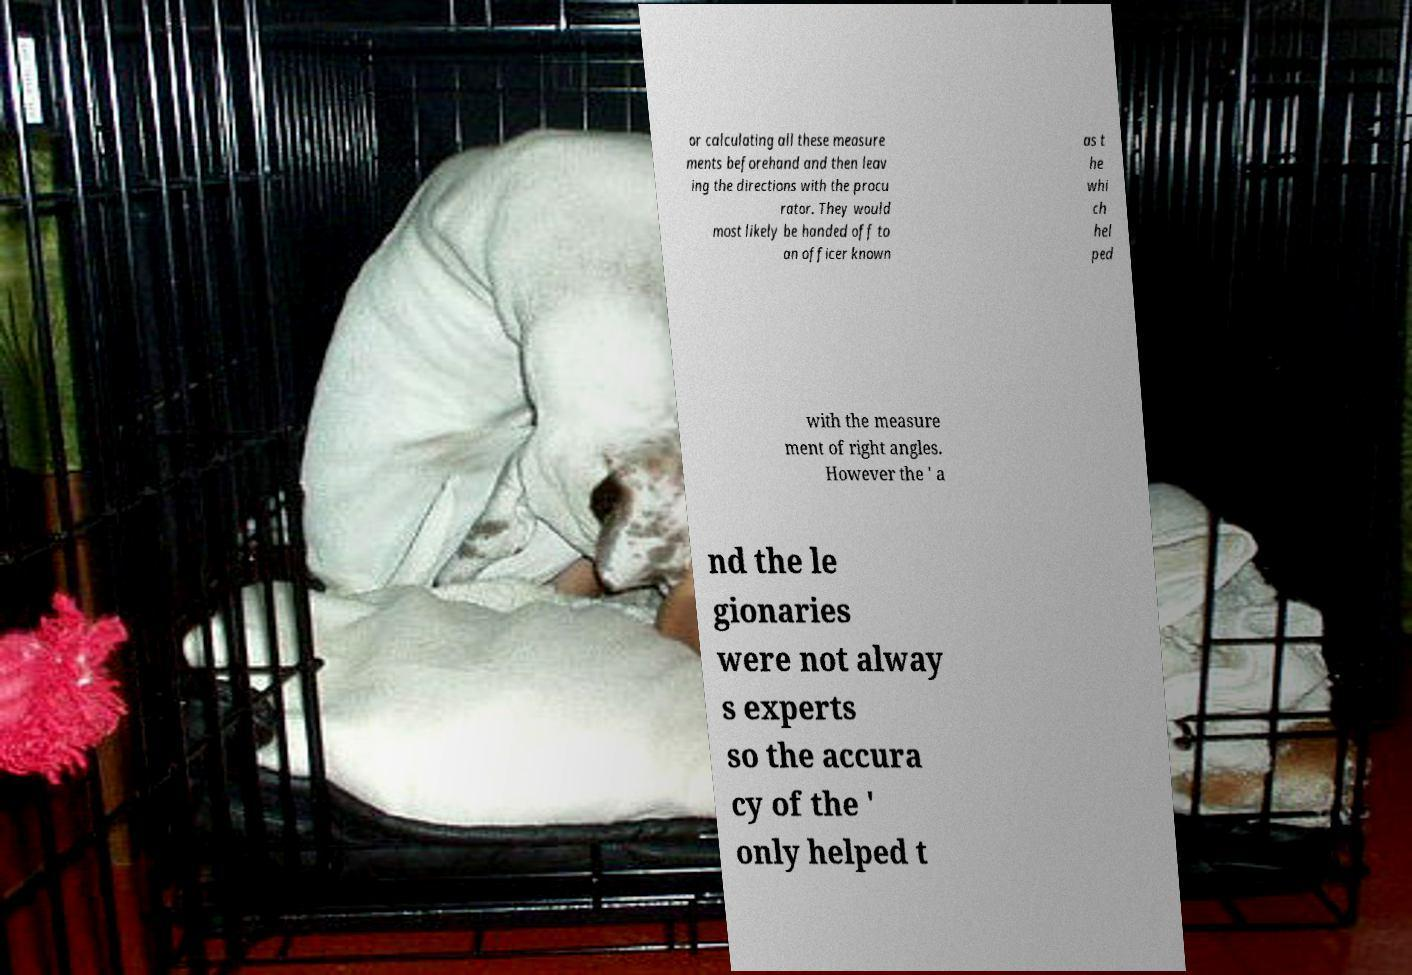I need the written content from this picture converted into text. Can you do that? or calculating all these measure ments beforehand and then leav ing the directions with the procu rator. They would most likely be handed off to an officer known as t he whi ch hel ped with the measure ment of right angles. However the ' a nd the le gionaries were not alway s experts so the accura cy of the ' only helped t 